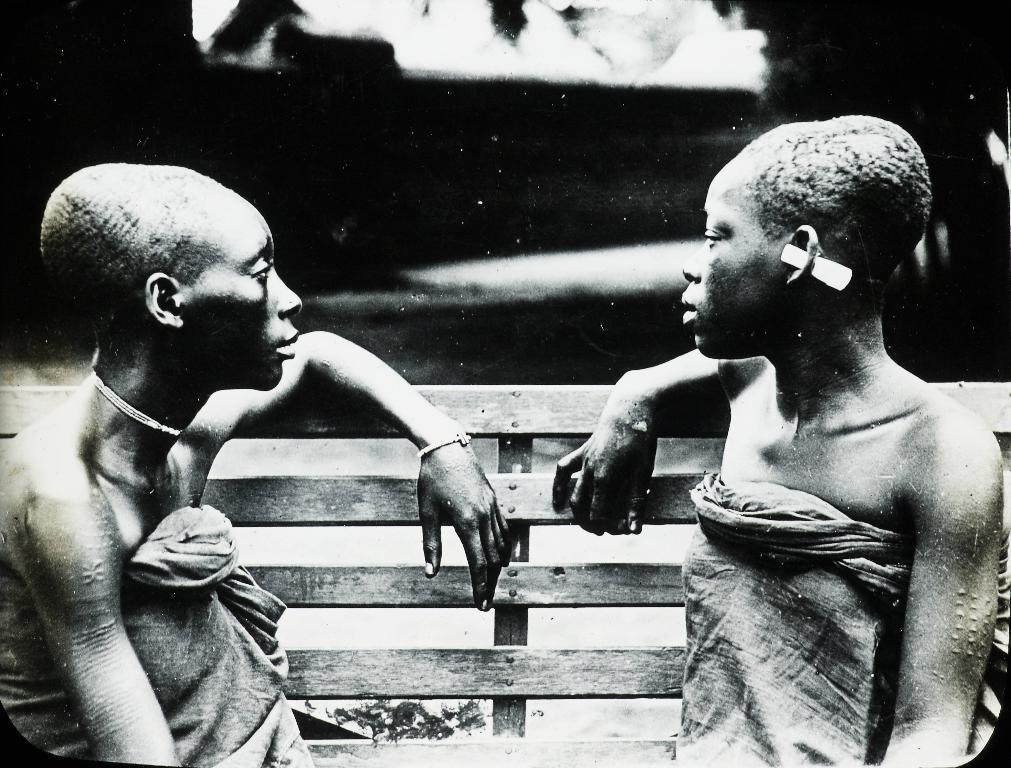How would you summarize this image in a sentence or two? In this image we can see black and white picture of two people sitting on a bench. 